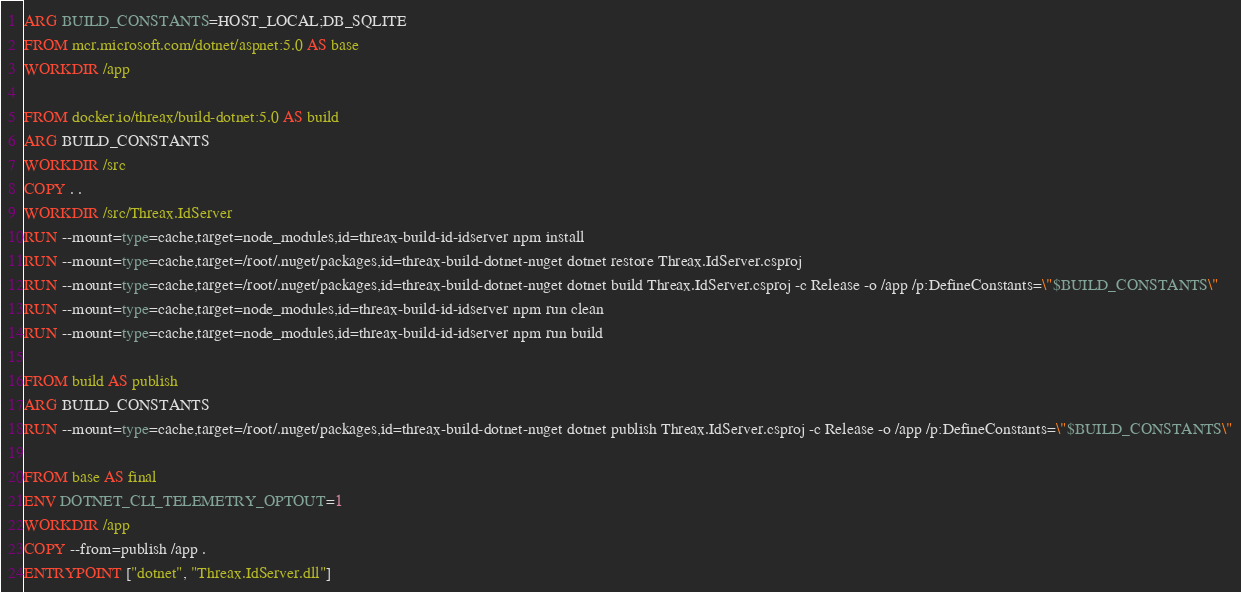Convert code to text. <code><loc_0><loc_0><loc_500><loc_500><_Dockerfile_>ARG BUILD_CONSTANTS=HOST_LOCAL;DB_SQLITE
FROM mcr.microsoft.com/dotnet/aspnet:5.0 AS base
WORKDIR /app

FROM docker.io/threax/build-dotnet:5.0 AS build
ARG BUILD_CONSTANTS
WORKDIR /src
COPY . .
WORKDIR /src/Threax.IdServer
RUN --mount=type=cache,target=node_modules,id=threax-build-id-idserver npm install
RUN --mount=type=cache,target=/root/.nuget/packages,id=threax-build-dotnet-nuget dotnet restore Threax.IdServer.csproj
RUN --mount=type=cache,target=/root/.nuget/packages,id=threax-build-dotnet-nuget dotnet build Threax.IdServer.csproj -c Release -o /app /p:DefineConstants=\"$BUILD_CONSTANTS\"
RUN --mount=type=cache,target=node_modules,id=threax-build-id-idserver npm run clean
RUN --mount=type=cache,target=node_modules,id=threax-build-id-idserver npm run build

FROM build AS publish
ARG BUILD_CONSTANTS
RUN --mount=type=cache,target=/root/.nuget/packages,id=threax-build-dotnet-nuget dotnet publish Threax.IdServer.csproj -c Release -o /app /p:DefineConstants=\"$BUILD_CONSTANTS\"

FROM base AS final
ENV DOTNET_CLI_TELEMETRY_OPTOUT=1
WORKDIR /app
COPY --from=publish /app .
ENTRYPOINT ["dotnet", "Threax.IdServer.dll"]
</code> 